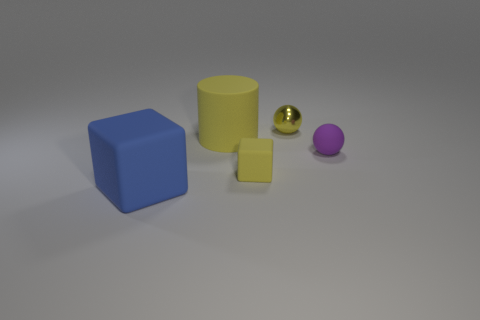Add 1 big brown objects. How many objects exist? 6 Subtract all cylinders. How many objects are left? 4 Add 1 purple matte balls. How many purple matte balls exist? 2 Subtract 1 yellow blocks. How many objects are left? 4 Subtract all big rubber cylinders. Subtract all matte cylinders. How many objects are left? 3 Add 2 small yellow things. How many small yellow things are left? 4 